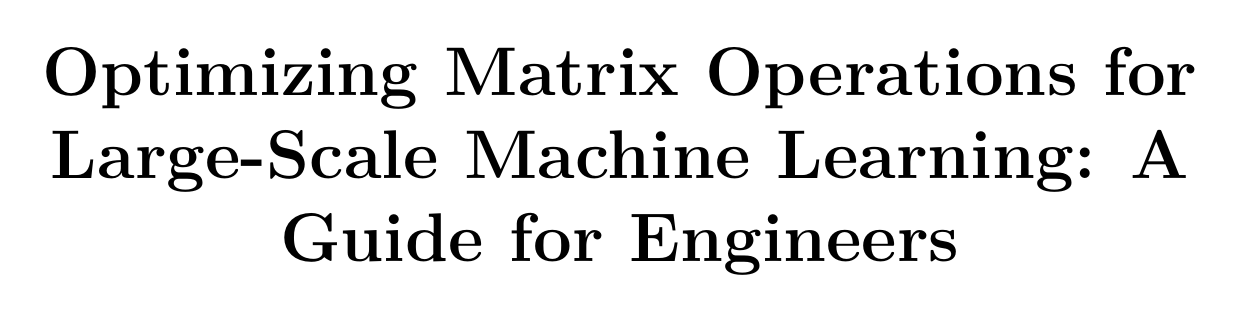What is the title of the manual? The title of the manual is stated at the beginning of the document.
Answer: Optimizing Matrix Operations for Large-Scale Machine Learning: A Guide for Engineers How many case studies are included in the manual? The number of case studies is found in the case studies section.
Answer: Three Which algorithm is discussed under parallel matrix multiplication? This algorithm appears in the parallel matrix multiplication algorithms chapter.
Answer: Strassen's algorithm What is the focus of the chapter on GPU-Accelerated Matrix Computations? This chapter outlines specific techniques relevant to GPU-processing of matrices.
Answer: CUDA-based matrix operations with cuBLAS Which library is mentioned for distributed linear algebra? The library is presented in the section on distributed linear algebra libraries.
Answer: ScaLAPACK What is one of the emerging technologies discussed in future directions? Emerging technologies are covered towards the end of the manual.
Answer: Quantum computing What is the main topic of the chapter on optimization techniques? This chapter discusses various optimization techniques for a specific type of matrix.
Answer: Sparse matrices What tool is mentioned for performance profiling in the manual? The tool is noted in the performance profiling and benchmarking chapter.
Answer: Not specified in the provided text 